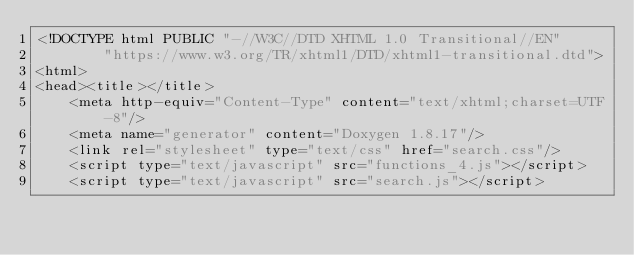Convert code to text. <code><loc_0><loc_0><loc_500><loc_500><_HTML_><!DOCTYPE html PUBLIC "-//W3C//DTD XHTML 1.0 Transitional//EN"
        "https://www.w3.org/TR/xhtml1/DTD/xhtml1-transitional.dtd">
<html>
<head><title></title>
    <meta http-equiv="Content-Type" content="text/xhtml;charset=UTF-8"/>
    <meta name="generator" content="Doxygen 1.8.17"/>
    <link rel="stylesheet" type="text/css" href="search.css"/>
    <script type="text/javascript" src="functions_4.js"></script>
    <script type="text/javascript" src="search.js"></script></code> 